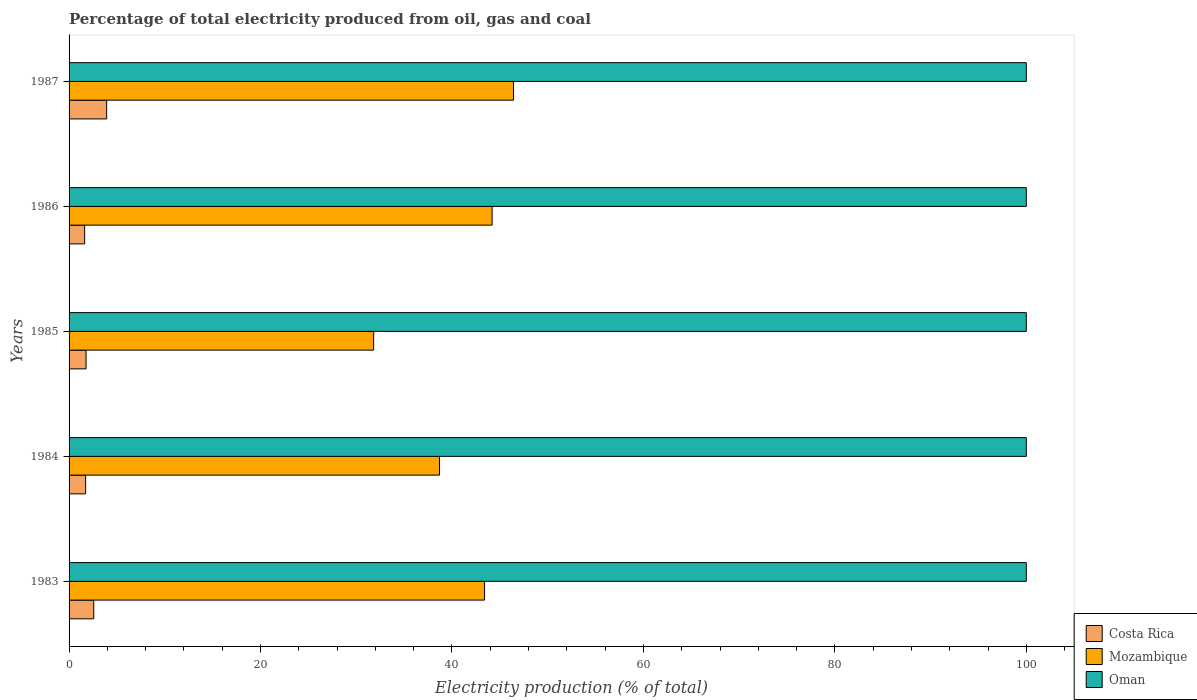How many groups of bars are there?
Offer a terse response. 5. How many bars are there on the 1st tick from the top?
Your answer should be compact. 3. What is the label of the 5th group of bars from the top?
Make the answer very short. 1983. Across all years, what is the maximum electricity production in in Costa Rica?
Make the answer very short. 3.93. Across all years, what is the minimum electricity production in in Oman?
Offer a terse response. 100. In which year was the electricity production in in Costa Rica minimum?
Make the answer very short. 1986. What is the difference between the electricity production in in Mozambique in 1986 and that in 1987?
Give a very brief answer. -2.24. What is the difference between the electricity production in in Mozambique in 1987 and the electricity production in in Oman in 1983?
Offer a very short reply. -53.57. In the year 1985, what is the difference between the electricity production in in Oman and electricity production in in Mozambique?
Keep it short and to the point. 68.18. What is the ratio of the electricity production in in Mozambique in 1984 to that in 1987?
Your response must be concise. 0.83. Is the difference between the electricity production in in Oman in 1983 and 1986 greater than the difference between the electricity production in in Mozambique in 1983 and 1986?
Provide a succinct answer. Yes. In how many years, is the electricity production in in Oman greater than the average electricity production in in Oman taken over all years?
Provide a succinct answer. 0. Is the sum of the electricity production in in Costa Rica in 1984 and 1985 greater than the maximum electricity production in in Mozambique across all years?
Your answer should be very brief. No. What does the 3rd bar from the top in 1983 represents?
Your answer should be compact. Costa Rica. What does the 1st bar from the bottom in 1984 represents?
Make the answer very short. Costa Rica. How many years are there in the graph?
Provide a short and direct response. 5. Are the values on the major ticks of X-axis written in scientific E-notation?
Offer a terse response. No. Does the graph contain any zero values?
Provide a short and direct response. No. Does the graph contain grids?
Keep it short and to the point. No. How many legend labels are there?
Your response must be concise. 3. How are the legend labels stacked?
Give a very brief answer. Vertical. What is the title of the graph?
Offer a terse response. Percentage of total electricity produced from oil, gas and coal. Does "Luxembourg" appear as one of the legend labels in the graph?
Your answer should be compact. No. What is the label or title of the X-axis?
Keep it short and to the point. Electricity production (% of total). What is the label or title of the Y-axis?
Ensure brevity in your answer.  Years. What is the Electricity production (% of total) in Costa Rica in 1983?
Provide a succinct answer. 2.58. What is the Electricity production (% of total) in Mozambique in 1983?
Your answer should be compact. 43.41. What is the Electricity production (% of total) in Costa Rica in 1984?
Keep it short and to the point. 1.73. What is the Electricity production (% of total) of Mozambique in 1984?
Your answer should be very brief. 38.69. What is the Electricity production (% of total) in Oman in 1984?
Keep it short and to the point. 100. What is the Electricity production (% of total) in Costa Rica in 1985?
Provide a succinct answer. 1.78. What is the Electricity production (% of total) of Mozambique in 1985?
Provide a short and direct response. 31.82. What is the Electricity production (% of total) of Oman in 1985?
Your response must be concise. 100. What is the Electricity production (% of total) of Costa Rica in 1986?
Offer a very short reply. 1.63. What is the Electricity production (% of total) of Mozambique in 1986?
Offer a terse response. 44.19. What is the Electricity production (% of total) in Costa Rica in 1987?
Ensure brevity in your answer.  3.93. What is the Electricity production (% of total) of Mozambique in 1987?
Provide a succinct answer. 46.43. What is the Electricity production (% of total) of Oman in 1987?
Your answer should be compact. 100. Across all years, what is the maximum Electricity production (% of total) of Costa Rica?
Provide a short and direct response. 3.93. Across all years, what is the maximum Electricity production (% of total) of Mozambique?
Give a very brief answer. 46.43. Across all years, what is the minimum Electricity production (% of total) of Costa Rica?
Offer a very short reply. 1.63. Across all years, what is the minimum Electricity production (% of total) of Mozambique?
Offer a terse response. 31.82. What is the total Electricity production (% of total) of Costa Rica in the graph?
Ensure brevity in your answer.  11.64. What is the total Electricity production (% of total) in Mozambique in the graph?
Your answer should be compact. 204.54. What is the difference between the Electricity production (% of total) of Costa Rica in 1983 and that in 1984?
Give a very brief answer. 0.85. What is the difference between the Electricity production (% of total) of Mozambique in 1983 and that in 1984?
Provide a short and direct response. 4.71. What is the difference between the Electricity production (% of total) of Oman in 1983 and that in 1984?
Make the answer very short. 0. What is the difference between the Electricity production (% of total) of Costa Rica in 1983 and that in 1985?
Give a very brief answer. 0.8. What is the difference between the Electricity production (% of total) of Mozambique in 1983 and that in 1985?
Offer a very short reply. 11.59. What is the difference between the Electricity production (% of total) of Oman in 1983 and that in 1985?
Offer a very short reply. 0. What is the difference between the Electricity production (% of total) of Costa Rica in 1983 and that in 1986?
Your answer should be very brief. 0.95. What is the difference between the Electricity production (% of total) in Mozambique in 1983 and that in 1986?
Offer a terse response. -0.79. What is the difference between the Electricity production (% of total) in Oman in 1983 and that in 1986?
Ensure brevity in your answer.  0. What is the difference between the Electricity production (% of total) in Costa Rica in 1983 and that in 1987?
Ensure brevity in your answer.  -1.35. What is the difference between the Electricity production (% of total) in Mozambique in 1983 and that in 1987?
Give a very brief answer. -3.02. What is the difference between the Electricity production (% of total) of Costa Rica in 1984 and that in 1985?
Your response must be concise. -0.05. What is the difference between the Electricity production (% of total) in Mozambique in 1984 and that in 1985?
Give a very brief answer. 6.88. What is the difference between the Electricity production (% of total) in Oman in 1984 and that in 1985?
Offer a terse response. 0. What is the difference between the Electricity production (% of total) of Costa Rica in 1984 and that in 1986?
Give a very brief answer. 0.1. What is the difference between the Electricity production (% of total) of Mozambique in 1984 and that in 1986?
Provide a succinct answer. -5.5. What is the difference between the Electricity production (% of total) of Oman in 1984 and that in 1986?
Your answer should be compact. 0. What is the difference between the Electricity production (% of total) of Costa Rica in 1984 and that in 1987?
Provide a short and direct response. -2.2. What is the difference between the Electricity production (% of total) in Mozambique in 1984 and that in 1987?
Your response must be concise. -7.74. What is the difference between the Electricity production (% of total) in Oman in 1984 and that in 1987?
Ensure brevity in your answer.  0. What is the difference between the Electricity production (% of total) of Costa Rica in 1985 and that in 1986?
Keep it short and to the point. 0.15. What is the difference between the Electricity production (% of total) in Mozambique in 1985 and that in 1986?
Give a very brief answer. -12.38. What is the difference between the Electricity production (% of total) of Oman in 1985 and that in 1986?
Your response must be concise. 0. What is the difference between the Electricity production (% of total) of Costa Rica in 1985 and that in 1987?
Give a very brief answer. -2.15. What is the difference between the Electricity production (% of total) of Mozambique in 1985 and that in 1987?
Offer a very short reply. -14.61. What is the difference between the Electricity production (% of total) of Costa Rica in 1986 and that in 1987?
Offer a very short reply. -2.3. What is the difference between the Electricity production (% of total) in Mozambique in 1986 and that in 1987?
Make the answer very short. -2.23. What is the difference between the Electricity production (% of total) in Costa Rica in 1983 and the Electricity production (% of total) in Mozambique in 1984?
Keep it short and to the point. -36.12. What is the difference between the Electricity production (% of total) of Costa Rica in 1983 and the Electricity production (% of total) of Oman in 1984?
Your answer should be very brief. -97.42. What is the difference between the Electricity production (% of total) in Mozambique in 1983 and the Electricity production (% of total) in Oman in 1984?
Provide a short and direct response. -56.59. What is the difference between the Electricity production (% of total) in Costa Rica in 1983 and the Electricity production (% of total) in Mozambique in 1985?
Make the answer very short. -29.24. What is the difference between the Electricity production (% of total) in Costa Rica in 1983 and the Electricity production (% of total) in Oman in 1985?
Your answer should be very brief. -97.42. What is the difference between the Electricity production (% of total) of Mozambique in 1983 and the Electricity production (% of total) of Oman in 1985?
Your response must be concise. -56.59. What is the difference between the Electricity production (% of total) of Costa Rica in 1983 and the Electricity production (% of total) of Mozambique in 1986?
Your answer should be compact. -41.62. What is the difference between the Electricity production (% of total) of Costa Rica in 1983 and the Electricity production (% of total) of Oman in 1986?
Provide a short and direct response. -97.42. What is the difference between the Electricity production (% of total) of Mozambique in 1983 and the Electricity production (% of total) of Oman in 1986?
Give a very brief answer. -56.59. What is the difference between the Electricity production (% of total) of Costa Rica in 1983 and the Electricity production (% of total) of Mozambique in 1987?
Make the answer very short. -43.85. What is the difference between the Electricity production (% of total) of Costa Rica in 1983 and the Electricity production (% of total) of Oman in 1987?
Offer a terse response. -97.42. What is the difference between the Electricity production (% of total) in Mozambique in 1983 and the Electricity production (% of total) in Oman in 1987?
Offer a very short reply. -56.59. What is the difference between the Electricity production (% of total) in Costa Rica in 1984 and the Electricity production (% of total) in Mozambique in 1985?
Offer a terse response. -30.09. What is the difference between the Electricity production (% of total) of Costa Rica in 1984 and the Electricity production (% of total) of Oman in 1985?
Your answer should be very brief. -98.27. What is the difference between the Electricity production (% of total) of Mozambique in 1984 and the Electricity production (% of total) of Oman in 1985?
Your answer should be very brief. -61.31. What is the difference between the Electricity production (% of total) in Costa Rica in 1984 and the Electricity production (% of total) in Mozambique in 1986?
Your answer should be very brief. -42.47. What is the difference between the Electricity production (% of total) in Costa Rica in 1984 and the Electricity production (% of total) in Oman in 1986?
Keep it short and to the point. -98.27. What is the difference between the Electricity production (% of total) in Mozambique in 1984 and the Electricity production (% of total) in Oman in 1986?
Make the answer very short. -61.31. What is the difference between the Electricity production (% of total) of Costa Rica in 1984 and the Electricity production (% of total) of Mozambique in 1987?
Give a very brief answer. -44.7. What is the difference between the Electricity production (% of total) in Costa Rica in 1984 and the Electricity production (% of total) in Oman in 1987?
Provide a succinct answer. -98.27. What is the difference between the Electricity production (% of total) in Mozambique in 1984 and the Electricity production (% of total) in Oman in 1987?
Your answer should be compact. -61.31. What is the difference between the Electricity production (% of total) in Costa Rica in 1985 and the Electricity production (% of total) in Mozambique in 1986?
Give a very brief answer. -42.42. What is the difference between the Electricity production (% of total) of Costa Rica in 1985 and the Electricity production (% of total) of Oman in 1986?
Your response must be concise. -98.22. What is the difference between the Electricity production (% of total) in Mozambique in 1985 and the Electricity production (% of total) in Oman in 1986?
Offer a terse response. -68.18. What is the difference between the Electricity production (% of total) in Costa Rica in 1985 and the Electricity production (% of total) in Mozambique in 1987?
Give a very brief answer. -44.65. What is the difference between the Electricity production (% of total) of Costa Rica in 1985 and the Electricity production (% of total) of Oman in 1987?
Provide a short and direct response. -98.22. What is the difference between the Electricity production (% of total) of Mozambique in 1985 and the Electricity production (% of total) of Oman in 1987?
Your answer should be compact. -68.18. What is the difference between the Electricity production (% of total) of Costa Rica in 1986 and the Electricity production (% of total) of Mozambique in 1987?
Give a very brief answer. -44.8. What is the difference between the Electricity production (% of total) in Costa Rica in 1986 and the Electricity production (% of total) in Oman in 1987?
Provide a short and direct response. -98.37. What is the difference between the Electricity production (% of total) in Mozambique in 1986 and the Electricity production (% of total) in Oman in 1987?
Ensure brevity in your answer.  -55.81. What is the average Electricity production (% of total) in Costa Rica per year?
Your response must be concise. 2.33. What is the average Electricity production (% of total) in Mozambique per year?
Keep it short and to the point. 40.91. In the year 1983, what is the difference between the Electricity production (% of total) in Costa Rica and Electricity production (% of total) in Mozambique?
Provide a succinct answer. -40.83. In the year 1983, what is the difference between the Electricity production (% of total) in Costa Rica and Electricity production (% of total) in Oman?
Your answer should be very brief. -97.42. In the year 1983, what is the difference between the Electricity production (% of total) in Mozambique and Electricity production (% of total) in Oman?
Provide a succinct answer. -56.59. In the year 1984, what is the difference between the Electricity production (% of total) in Costa Rica and Electricity production (% of total) in Mozambique?
Ensure brevity in your answer.  -36.97. In the year 1984, what is the difference between the Electricity production (% of total) of Costa Rica and Electricity production (% of total) of Oman?
Ensure brevity in your answer.  -98.27. In the year 1984, what is the difference between the Electricity production (% of total) in Mozambique and Electricity production (% of total) in Oman?
Your answer should be compact. -61.31. In the year 1985, what is the difference between the Electricity production (% of total) of Costa Rica and Electricity production (% of total) of Mozambique?
Offer a terse response. -30.04. In the year 1985, what is the difference between the Electricity production (% of total) of Costa Rica and Electricity production (% of total) of Oman?
Give a very brief answer. -98.22. In the year 1985, what is the difference between the Electricity production (% of total) in Mozambique and Electricity production (% of total) in Oman?
Keep it short and to the point. -68.18. In the year 1986, what is the difference between the Electricity production (% of total) in Costa Rica and Electricity production (% of total) in Mozambique?
Provide a short and direct response. -42.57. In the year 1986, what is the difference between the Electricity production (% of total) of Costa Rica and Electricity production (% of total) of Oman?
Provide a short and direct response. -98.37. In the year 1986, what is the difference between the Electricity production (% of total) in Mozambique and Electricity production (% of total) in Oman?
Make the answer very short. -55.81. In the year 1987, what is the difference between the Electricity production (% of total) of Costa Rica and Electricity production (% of total) of Mozambique?
Your answer should be compact. -42.5. In the year 1987, what is the difference between the Electricity production (% of total) of Costa Rica and Electricity production (% of total) of Oman?
Make the answer very short. -96.07. In the year 1987, what is the difference between the Electricity production (% of total) of Mozambique and Electricity production (% of total) of Oman?
Ensure brevity in your answer.  -53.57. What is the ratio of the Electricity production (% of total) in Costa Rica in 1983 to that in 1984?
Offer a terse response. 1.49. What is the ratio of the Electricity production (% of total) of Mozambique in 1983 to that in 1984?
Your answer should be very brief. 1.12. What is the ratio of the Electricity production (% of total) in Oman in 1983 to that in 1984?
Ensure brevity in your answer.  1. What is the ratio of the Electricity production (% of total) in Costa Rica in 1983 to that in 1985?
Your response must be concise. 1.45. What is the ratio of the Electricity production (% of total) in Mozambique in 1983 to that in 1985?
Keep it short and to the point. 1.36. What is the ratio of the Electricity production (% of total) in Costa Rica in 1983 to that in 1986?
Your answer should be very brief. 1.58. What is the ratio of the Electricity production (% of total) in Mozambique in 1983 to that in 1986?
Your answer should be very brief. 0.98. What is the ratio of the Electricity production (% of total) in Oman in 1983 to that in 1986?
Your answer should be very brief. 1. What is the ratio of the Electricity production (% of total) in Costa Rica in 1983 to that in 1987?
Offer a very short reply. 0.66. What is the ratio of the Electricity production (% of total) of Mozambique in 1983 to that in 1987?
Offer a very short reply. 0.93. What is the ratio of the Electricity production (% of total) of Oman in 1983 to that in 1987?
Give a very brief answer. 1. What is the ratio of the Electricity production (% of total) of Costa Rica in 1984 to that in 1985?
Keep it short and to the point. 0.97. What is the ratio of the Electricity production (% of total) in Mozambique in 1984 to that in 1985?
Your answer should be compact. 1.22. What is the ratio of the Electricity production (% of total) of Oman in 1984 to that in 1985?
Your response must be concise. 1. What is the ratio of the Electricity production (% of total) of Costa Rica in 1984 to that in 1986?
Keep it short and to the point. 1.06. What is the ratio of the Electricity production (% of total) of Mozambique in 1984 to that in 1986?
Your answer should be very brief. 0.88. What is the ratio of the Electricity production (% of total) in Oman in 1984 to that in 1986?
Make the answer very short. 1. What is the ratio of the Electricity production (% of total) of Costa Rica in 1984 to that in 1987?
Keep it short and to the point. 0.44. What is the ratio of the Electricity production (% of total) of Mozambique in 1984 to that in 1987?
Keep it short and to the point. 0.83. What is the ratio of the Electricity production (% of total) in Oman in 1984 to that in 1987?
Provide a short and direct response. 1. What is the ratio of the Electricity production (% of total) in Costa Rica in 1985 to that in 1986?
Give a very brief answer. 1.09. What is the ratio of the Electricity production (% of total) in Mozambique in 1985 to that in 1986?
Provide a short and direct response. 0.72. What is the ratio of the Electricity production (% of total) of Oman in 1985 to that in 1986?
Provide a succinct answer. 1. What is the ratio of the Electricity production (% of total) of Costa Rica in 1985 to that in 1987?
Make the answer very short. 0.45. What is the ratio of the Electricity production (% of total) in Mozambique in 1985 to that in 1987?
Provide a succinct answer. 0.69. What is the ratio of the Electricity production (% of total) of Costa Rica in 1986 to that in 1987?
Keep it short and to the point. 0.41. What is the ratio of the Electricity production (% of total) of Mozambique in 1986 to that in 1987?
Ensure brevity in your answer.  0.95. What is the ratio of the Electricity production (% of total) of Oman in 1986 to that in 1987?
Provide a succinct answer. 1. What is the difference between the highest and the second highest Electricity production (% of total) in Costa Rica?
Make the answer very short. 1.35. What is the difference between the highest and the second highest Electricity production (% of total) of Mozambique?
Your answer should be very brief. 2.23. What is the difference between the highest and the second highest Electricity production (% of total) in Oman?
Keep it short and to the point. 0. What is the difference between the highest and the lowest Electricity production (% of total) in Costa Rica?
Give a very brief answer. 2.3. What is the difference between the highest and the lowest Electricity production (% of total) in Mozambique?
Offer a very short reply. 14.61. 